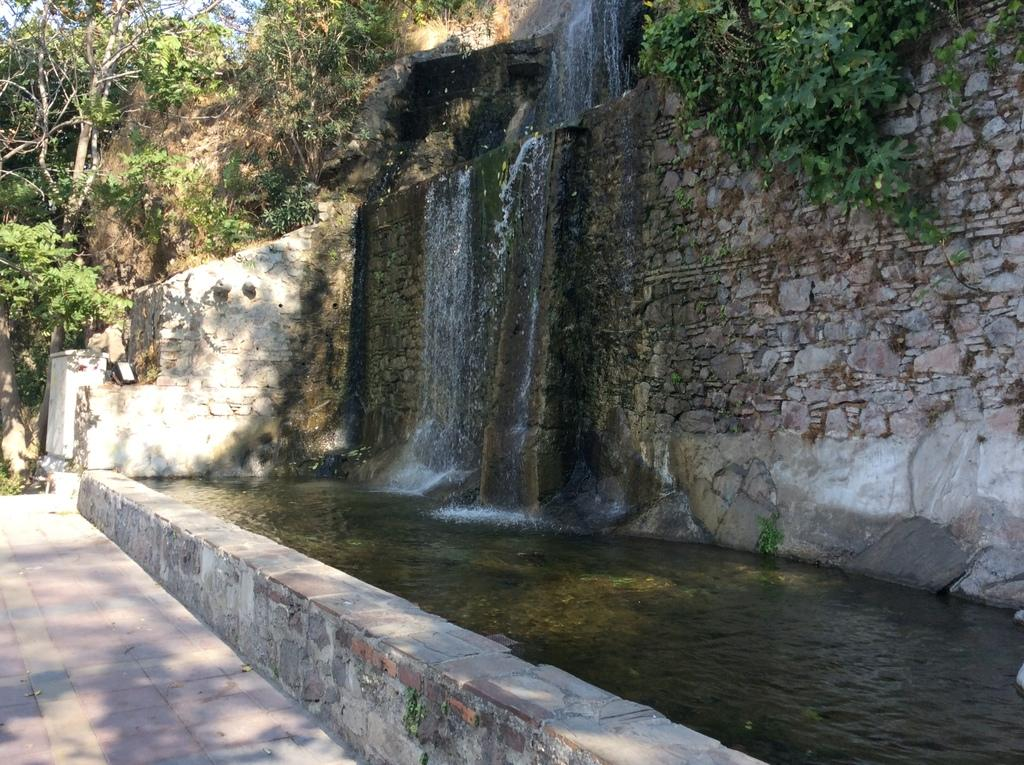What natural feature is the main subject of the picture? There is a waterfall in the picture. What other elements can be seen in the picture? There are plants and trees in the picture. What type of receipt can be seen near the waterfall in the image? There is no receipt present in the image; it features a waterfall, plants, and trees. What kind of request is being made by the waterfall in the image? Waterfalls do not make requests, as they are natural features and not capable of making such actions. 